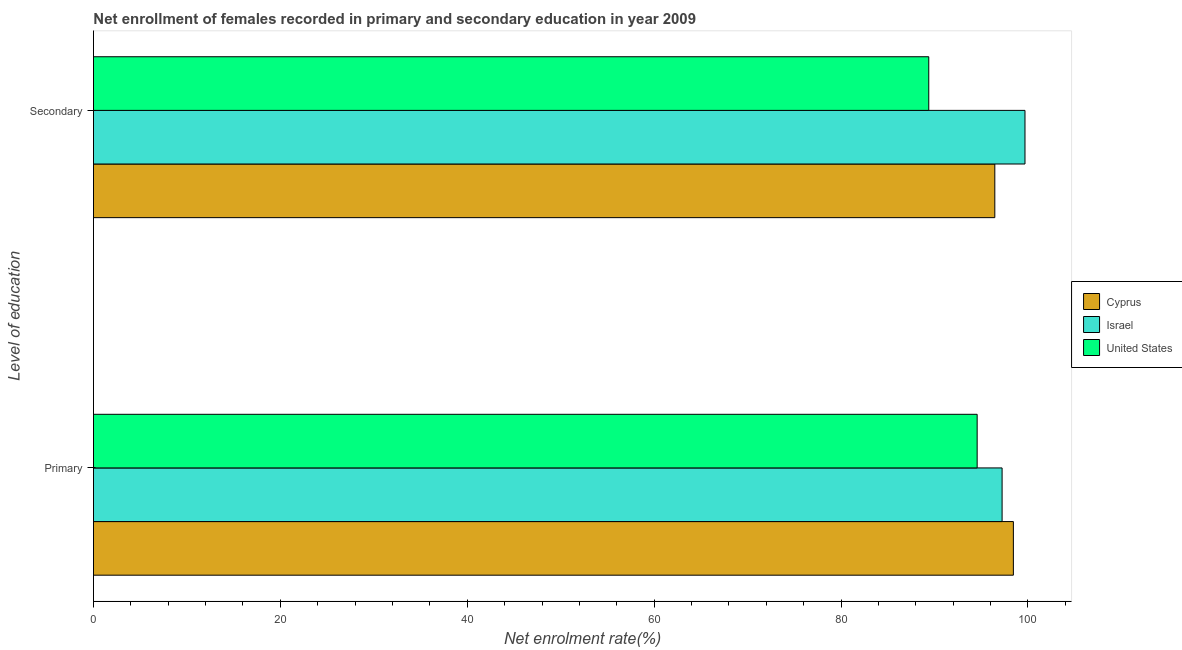How many different coloured bars are there?
Give a very brief answer. 3. Are the number of bars per tick equal to the number of legend labels?
Make the answer very short. Yes. How many bars are there on the 2nd tick from the top?
Your answer should be very brief. 3. What is the label of the 1st group of bars from the top?
Give a very brief answer. Secondary. What is the enrollment rate in secondary education in United States?
Give a very brief answer. 89.39. Across all countries, what is the maximum enrollment rate in primary education?
Give a very brief answer. 98.45. Across all countries, what is the minimum enrollment rate in primary education?
Your answer should be compact. 94.57. In which country was the enrollment rate in primary education maximum?
Offer a terse response. Cyprus. What is the total enrollment rate in primary education in the graph?
Offer a very short reply. 290.25. What is the difference between the enrollment rate in primary education in Cyprus and that in Israel?
Make the answer very short. 1.21. What is the difference between the enrollment rate in primary education in Cyprus and the enrollment rate in secondary education in Israel?
Ensure brevity in your answer.  -1.24. What is the average enrollment rate in primary education per country?
Keep it short and to the point. 96.75. What is the difference between the enrollment rate in secondary education and enrollment rate in primary education in United States?
Give a very brief answer. -5.18. What is the ratio of the enrollment rate in secondary education in Israel to that in United States?
Make the answer very short. 1.12. Is the enrollment rate in secondary education in United States less than that in Israel?
Offer a terse response. Yes. What does the 2nd bar from the bottom in Primary represents?
Offer a very short reply. Israel. How many bars are there?
Provide a succinct answer. 6. What is the difference between two consecutive major ticks on the X-axis?
Make the answer very short. 20. Are the values on the major ticks of X-axis written in scientific E-notation?
Offer a terse response. No. Does the graph contain any zero values?
Make the answer very short. No. What is the title of the graph?
Your response must be concise. Net enrollment of females recorded in primary and secondary education in year 2009. What is the label or title of the X-axis?
Ensure brevity in your answer.  Net enrolment rate(%). What is the label or title of the Y-axis?
Provide a short and direct response. Level of education. What is the Net enrolment rate(%) in Cyprus in Primary?
Keep it short and to the point. 98.45. What is the Net enrolment rate(%) of Israel in Primary?
Provide a succinct answer. 97.24. What is the Net enrolment rate(%) of United States in Primary?
Your response must be concise. 94.57. What is the Net enrolment rate(%) in Cyprus in Secondary?
Provide a succinct answer. 96.46. What is the Net enrolment rate(%) in Israel in Secondary?
Provide a short and direct response. 99.69. What is the Net enrolment rate(%) in United States in Secondary?
Give a very brief answer. 89.39. Across all Level of education, what is the maximum Net enrolment rate(%) of Cyprus?
Keep it short and to the point. 98.45. Across all Level of education, what is the maximum Net enrolment rate(%) in Israel?
Give a very brief answer. 99.69. Across all Level of education, what is the maximum Net enrolment rate(%) in United States?
Provide a short and direct response. 94.57. Across all Level of education, what is the minimum Net enrolment rate(%) of Cyprus?
Offer a very short reply. 96.46. Across all Level of education, what is the minimum Net enrolment rate(%) in Israel?
Ensure brevity in your answer.  97.24. Across all Level of education, what is the minimum Net enrolment rate(%) in United States?
Keep it short and to the point. 89.39. What is the total Net enrolment rate(%) in Cyprus in the graph?
Offer a terse response. 194.91. What is the total Net enrolment rate(%) of Israel in the graph?
Keep it short and to the point. 196.93. What is the total Net enrolment rate(%) of United States in the graph?
Your response must be concise. 183.96. What is the difference between the Net enrolment rate(%) of Cyprus in Primary and that in Secondary?
Your answer should be very brief. 1.99. What is the difference between the Net enrolment rate(%) in Israel in Primary and that in Secondary?
Provide a short and direct response. -2.45. What is the difference between the Net enrolment rate(%) of United States in Primary and that in Secondary?
Offer a very short reply. 5.18. What is the difference between the Net enrolment rate(%) in Cyprus in Primary and the Net enrolment rate(%) in Israel in Secondary?
Give a very brief answer. -1.24. What is the difference between the Net enrolment rate(%) in Cyprus in Primary and the Net enrolment rate(%) in United States in Secondary?
Give a very brief answer. 9.05. What is the difference between the Net enrolment rate(%) of Israel in Primary and the Net enrolment rate(%) of United States in Secondary?
Ensure brevity in your answer.  7.85. What is the average Net enrolment rate(%) of Cyprus per Level of education?
Provide a short and direct response. 97.45. What is the average Net enrolment rate(%) of Israel per Level of education?
Provide a short and direct response. 98.46. What is the average Net enrolment rate(%) in United States per Level of education?
Ensure brevity in your answer.  91.98. What is the difference between the Net enrolment rate(%) of Cyprus and Net enrolment rate(%) of Israel in Primary?
Make the answer very short. 1.21. What is the difference between the Net enrolment rate(%) of Cyprus and Net enrolment rate(%) of United States in Primary?
Offer a very short reply. 3.88. What is the difference between the Net enrolment rate(%) of Israel and Net enrolment rate(%) of United States in Primary?
Make the answer very short. 2.67. What is the difference between the Net enrolment rate(%) of Cyprus and Net enrolment rate(%) of Israel in Secondary?
Keep it short and to the point. -3.23. What is the difference between the Net enrolment rate(%) in Cyprus and Net enrolment rate(%) in United States in Secondary?
Your response must be concise. 7.07. What is the difference between the Net enrolment rate(%) of Israel and Net enrolment rate(%) of United States in Secondary?
Keep it short and to the point. 10.3. What is the ratio of the Net enrolment rate(%) in Cyprus in Primary to that in Secondary?
Offer a very short reply. 1.02. What is the ratio of the Net enrolment rate(%) in Israel in Primary to that in Secondary?
Provide a succinct answer. 0.98. What is the ratio of the Net enrolment rate(%) in United States in Primary to that in Secondary?
Your answer should be compact. 1.06. What is the difference between the highest and the second highest Net enrolment rate(%) of Cyprus?
Provide a short and direct response. 1.99. What is the difference between the highest and the second highest Net enrolment rate(%) of Israel?
Your answer should be compact. 2.45. What is the difference between the highest and the second highest Net enrolment rate(%) of United States?
Keep it short and to the point. 5.18. What is the difference between the highest and the lowest Net enrolment rate(%) in Cyprus?
Provide a short and direct response. 1.99. What is the difference between the highest and the lowest Net enrolment rate(%) in Israel?
Offer a terse response. 2.45. What is the difference between the highest and the lowest Net enrolment rate(%) in United States?
Offer a terse response. 5.18. 